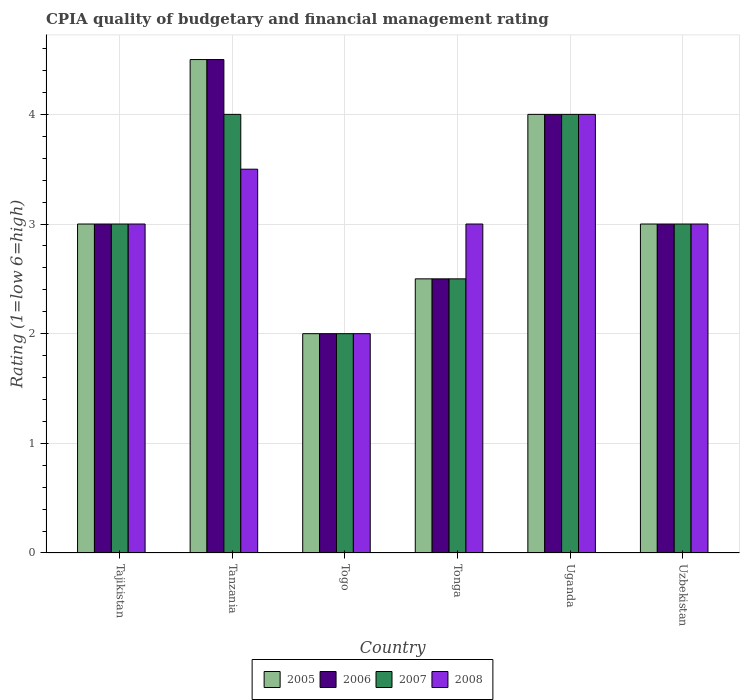How many groups of bars are there?
Ensure brevity in your answer.  6. Are the number of bars on each tick of the X-axis equal?
Offer a terse response. Yes. How many bars are there on the 4th tick from the left?
Your answer should be very brief. 4. What is the label of the 4th group of bars from the left?
Provide a succinct answer. Tonga. Across all countries, what is the maximum CPIA rating in 2005?
Give a very brief answer. 4.5. In which country was the CPIA rating in 2006 maximum?
Keep it short and to the point. Tanzania. In which country was the CPIA rating in 2007 minimum?
Offer a terse response. Togo. What is the total CPIA rating in 2005 in the graph?
Make the answer very short. 19. What is the difference between the CPIA rating in 2007 in Tanzania and that in Togo?
Your answer should be compact. 2. What is the average CPIA rating in 2005 per country?
Offer a terse response. 3.17. What is the ratio of the CPIA rating in 2005 in Tonga to that in Uzbekistan?
Provide a succinct answer. 0.83. Is the difference between the CPIA rating in 2006 in Tanzania and Uganda greater than the difference between the CPIA rating in 2005 in Tanzania and Uganda?
Make the answer very short. No. In how many countries, is the CPIA rating in 2008 greater than the average CPIA rating in 2008 taken over all countries?
Your response must be concise. 2. Is the sum of the CPIA rating in 2005 in Tanzania and Uganda greater than the maximum CPIA rating in 2006 across all countries?
Make the answer very short. Yes. Is it the case that in every country, the sum of the CPIA rating in 2008 and CPIA rating in 2005 is greater than the sum of CPIA rating in 2006 and CPIA rating in 2007?
Give a very brief answer. No. What does the 3rd bar from the left in Tajikistan represents?
Offer a terse response. 2007. What is the difference between two consecutive major ticks on the Y-axis?
Make the answer very short. 1. Does the graph contain any zero values?
Your answer should be compact. No. Does the graph contain grids?
Provide a short and direct response. Yes. How are the legend labels stacked?
Offer a terse response. Horizontal. What is the title of the graph?
Keep it short and to the point. CPIA quality of budgetary and financial management rating. What is the label or title of the X-axis?
Your response must be concise. Country. What is the label or title of the Y-axis?
Provide a short and direct response. Rating (1=low 6=high). What is the Rating (1=low 6=high) in 2005 in Tajikistan?
Provide a short and direct response. 3. What is the Rating (1=low 6=high) of 2006 in Tajikistan?
Offer a very short reply. 3. What is the Rating (1=low 6=high) of 2007 in Tajikistan?
Offer a very short reply. 3. What is the Rating (1=low 6=high) of 2008 in Tajikistan?
Your answer should be very brief. 3. What is the Rating (1=low 6=high) in 2005 in Tanzania?
Give a very brief answer. 4.5. What is the Rating (1=low 6=high) in 2007 in Tanzania?
Offer a very short reply. 4. What is the Rating (1=low 6=high) in 2006 in Togo?
Provide a succinct answer. 2. What is the Rating (1=low 6=high) in 2007 in Togo?
Your answer should be very brief. 2. What is the Rating (1=low 6=high) of 2008 in Togo?
Provide a short and direct response. 2. What is the Rating (1=low 6=high) in 2005 in Tonga?
Your response must be concise. 2.5. What is the Rating (1=low 6=high) of 2006 in Tonga?
Ensure brevity in your answer.  2.5. What is the Rating (1=low 6=high) in 2007 in Tonga?
Give a very brief answer. 2.5. What is the Rating (1=low 6=high) in 2008 in Tonga?
Your answer should be very brief. 3. What is the Rating (1=low 6=high) of 2006 in Uganda?
Ensure brevity in your answer.  4. What is the Rating (1=low 6=high) of 2008 in Uganda?
Your answer should be compact. 4. What is the Rating (1=low 6=high) in 2007 in Uzbekistan?
Make the answer very short. 3. Across all countries, what is the maximum Rating (1=low 6=high) in 2007?
Keep it short and to the point. 4. Across all countries, what is the maximum Rating (1=low 6=high) of 2008?
Give a very brief answer. 4. What is the total Rating (1=low 6=high) of 2006 in the graph?
Offer a very short reply. 19. What is the total Rating (1=low 6=high) of 2008 in the graph?
Ensure brevity in your answer.  18.5. What is the difference between the Rating (1=low 6=high) in 2007 in Tajikistan and that in Tanzania?
Your answer should be compact. -1. What is the difference between the Rating (1=low 6=high) of 2007 in Tajikistan and that in Tonga?
Ensure brevity in your answer.  0.5. What is the difference between the Rating (1=low 6=high) of 2008 in Tajikistan and that in Tonga?
Keep it short and to the point. 0. What is the difference between the Rating (1=low 6=high) in 2005 in Tajikistan and that in Uganda?
Provide a succinct answer. -1. What is the difference between the Rating (1=low 6=high) of 2006 in Tajikistan and that in Uganda?
Your response must be concise. -1. What is the difference between the Rating (1=low 6=high) in 2006 in Tajikistan and that in Uzbekistan?
Your response must be concise. 0. What is the difference between the Rating (1=low 6=high) in 2005 in Tanzania and that in Togo?
Your answer should be compact. 2.5. What is the difference between the Rating (1=low 6=high) in 2008 in Tanzania and that in Togo?
Offer a terse response. 1.5. What is the difference between the Rating (1=low 6=high) in 2005 in Tanzania and that in Tonga?
Give a very brief answer. 2. What is the difference between the Rating (1=low 6=high) in 2006 in Tanzania and that in Tonga?
Ensure brevity in your answer.  2. What is the difference between the Rating (1=low 6=high) of 2008 in Tanzania and that in Uganda?
Make the answer very short. -0.5. What is the difference between the Rating (1=low 6=high) in 2005 in Tanzania and that in Uzbekistan?
Give a very brief answer. 1.5. What is the difference between the Rating (1=low 6=high) of 2007 in Tanzania and that in Uzbekistan?
Offer a very short reply. 1. What is the difference between the Rating (1=low 6=high) in 2007 in Togo and that in Tonga?
Keep it short and to the point. -0.5. What is the difference between the Rating (1=low 6=high) in 2008 in Togo and that in Tonga?
Make the answer very short. -1. What is the difference between the Rating (1=low 6=high) in 2005 in Togo and that in Uganda?
Give a very brief answer. -2. What is the difference between the Rating (1=low 6=high) of 2007 in Togo and that in Uganda?
Provide a short and direct response. -2. What is the difference between the Rating (1=low 6=high) of 2008 in Togo and that in Uganda?
Keep it short and to the point. -2. What is the difference between the Rating (1=low 6=high) in 2006 in Togo and that in Uzbekistan?
Ensure brevity in your answer.  -1. What is the difference between the Rating (1=low 6=high) in 2008 in Tonga and that in Uganda?
Ensure brevity in your answer.  -1. What is the difference between the Rating (1=low 6=high) in 2006 in Tonga and that in Uzbekistan?
Offer a very short reply. -0.5. What is the difference between the Rating (1=low 6=high) in 2005 in Uganda and that in Uzbekistan?
Your response must be concise. 1. What is the difference between the Rating (1=low 6=high) in 2007 in Uganda and that in Uzbekistan?
Offer a very short reply. 1. What is the difference between the Rating (1=low 6=high) of 2008 in Uganda and that in Uzbekistan?
Offer a very short reply. 1. What is the difference between the Rating (1=low 6=high) of 2005 in Tajikistan and the Rating (1=low 6=high) of 2008 in Tanzania?
Ensure brevity in your answer.  -0.5. What is the difference between the Rating (1=low 6=high) in 2006 in Tajikistan and the Rating (1=low 6=high) in 2007 in Tanzania?
Make the answer very short. -1. What is the difference between the Rating (1=low 6=high) in 2007 in Tajikistan and the Rating (1=low 6=high) in 2008 in Tanzania?
Offer a very short reply. -0.5. What is the difference between the Rating (1=low 6=high) in 2005 in Tajikistan and the Rating (1=low 6=high) in 2006 in Togo?
Provide a short and direct response. 1. What is the difference between the Rating (1=low 6=high) of 2005 in Tajikistan and the Rating (1=low 6=high) of 2007 in Togo?
Provide a short and direct response. 1. What is the difference between the Rating (1=low 6=high) in 2005 in Tajikistan and the Rating (1=low 6=high) in 2008 in Togo?
Offer a terse response. 1. What is the difference between the Rating (1=low 6=high) in 2006 in Tajikistan and the Rating (1=low 6=high) in 2008 in Togo?
Your answer should be compact. 1. What is the difference between the Rating (1=low 6=high) of 2007 in Tajikistan and the Rating (1=low 6=high) of 2008 in Togo?
Your answer should be compact. 1. What is the difference between the Rating (1=low 6=high) in 2005 in Tajikistan and the Rating (1=low 6=high) in 2006 in Tonga?
Ensure brevity in your answer.  0.5. What is the difference between the Rating (1=low 6=high) in 2006 in Tajikistan and the Rating (1=low 6=high) in 2007 in Tonga?
Your answer should be very brief. 0.5. What is the difference between the Rating (1=low 6=high) in 2005 in Tajikistan and the Rating (1=low 6=high) in 2008 in Uganda?
Provide a short and direct response. -1. What is the difference between the Rating (1=low 6=high) of 2007 in Tajikistan and the Rating (1=low 6=high) of 2008 in Uganda?
Your response must be concise. -1. What is the difference between the Rating (1=low 6=high) in 2005 in Tajikistan and the Rating (1=low 6=high) in 2007 in Uzbekistan?
Offer a very short reply. 0. What is the difference between the Rating (1=low 6=high) of 2006 in Tajikistan and the Rating (1=low 6=high) of 2007 in Uzbekistan?
Offer a terse response. 0. What is the difference between the Rating (1=low 6=high) in 2006 in Tajikistan and the Rating (1=low 6=high) in 2008 in Uzbekistan?
Give a very brief answer. 0. What is the difference between the Rating (1=low 6=high) in 2005 in Tanzania and the Rating (1=low 6=high) in 2006 in Togo?
Provide a succinct answer. 2.5. What is the difference between the Rating (1=low 6=high) of 2006 in Tanzania and the Rating (1=low 6=high) of 2008 in Togo?
Offer a terse response. 2.5. What is the difference between the Rating (1=low 6=high) in 2005 in Tanzania and the Rating (1=low 6=high) in 2007 in Tonga?
Your response must be concise. 2. What is the difference between the Rating (1=low 6=high) in 2005 in Tanzania and the Rating (1=low 6=high) in 2008 in Tonga?
Provide a succinct answer. 1.5. What is the difference between the Rating (1=low 6=high) of 2006 in Tanzania and the Rating (1=low 6=high) of 2008 in Tonga?
Make the answer very short. 1.5. What is the difference between the Rating (1=low 6=high) in 2005 in Tanzania and the Rating (1=low 6=high) in 2007 in Uganda?
Keep it short and to the point. 0.5. What is the difference between the Rating (1=low 6=high) in 2005 in Tanzania and the Rating (1=low 6=high) in 2008 in Uganda?
Keep it short and to the point. 0.5. What is the difference between the Rating (1=low 6=high) in 2006 in Tanzania and the Rating (1=low 6=high) in 2008 in Uganda?
Make the answer very short. 0.5. What is the difference between the Rating (1=low 6=high) in 2005 in Tanzania and the Rating (1=low 6=high) in 2006 in Uzbekistan?
Give a very brief answer. 1.5. What is the difference between the Rating (1=low 6=high) of 2005 in Tanzania and the Rating (1=low 6=high) of 2007 in Uzbekistan?
Make the answer very short. 1.5. What is the difference between the Rating (1=low 6=high) of 2006 in Tanzania and the Rating (1=low 6=high) of 2007 in Uzbekistan?
Your answer should be compact. 1.5. What is the difference between the Rating (1=low 6=high) in 2007 in Tanzania and the Rating (1=low 6=high) in 2008 in Uzbekistan?
Offer a terse response. 1. What is the difference between the Rating (1=low 6=high) of 2005 in Togo and the Rating (1=low 6=high) of 2006 in Tonga?
Offer a very short reply. -0.5. What is the difference between the Rating (1=low 6=high) in 2005 in Togo and the Rating (1=low 6=high) in 2008 in Tonga?
Your response must be concise. -1. What is the difference between the Rating (1=low 6=high) of 2006 in Togo and the Rating (1=low 6=high) of 2007 in Tonga?
Ensure brevity in your answer.  -0.5. What is the difference between the Rating (1=low 6=high) in 2006 in Togo and the Rating (1=low 6=high) in 2008 in Tonga?
Provide a succinct answer. -1. What is the difference between the Rating (1=low 6=high) in 2007 in Togo and the Rating (1=low 6=high) in 2008 in Tonga?
Offer a very short reply. -1. What is the difference between the Rating (1=low 6=high) in 2006 in Togo and the Rating (1=low 6=high) in 2008 in Uganda?
Give a very brief answer. -2. What is the difference between the Rating (1=low 6=high) of 2007 in Togo and the Rating (1=low 6=high) of 2008 in Uganda?
Provide a short and direct response. -2. What is the difference between the Rating (1=low 6=high) of 2005 in Togo and the Rating (1=low 6=high) of 2006 in Uzbekistan?
Make the answer very short. -1. What is the difference between the Rating (1=low 6=high) of 2005 in Togo and the Rating (1=low 6=high) of 2007 in Uzbekistan?
Ensure brevity in your answer.  -1. What is the difference between the Rating (1=low 6=high) in 2006 in Togo and the Rating (1=low 6=high) in 2007 in Uzbekistan?
Offer a terse response. -1. What is the difference between the Rating (1=low 6=high) of 2007 in Togo and the Rating (1=low 6=high) of 2008 in Uzbekistan?
Provide a succinct answer. -1. What is the difference between the Rating (1=low 6=high) of 2005 in Tonga and the Rating (1=low 6=high) of 2008 in Uganda?
Your answer should be compact. -1.5. What is the difference between the Rating (1=low 6=high) in 2006 in Tonga and the Rating (1=low 6=high) in 2007 in Uganda?
Keep it short and to the point. -1.5. What is the difference between the Rating (1=low 6=high) in 2005 in Tonga and the Rating (1=low 6=high) in 2006 in Uzbekistan?
Keep it short and to the point. -0.5. What is the difference between the Rating (1=low 6=high) of 2005 in Tonga and the Rating (1=low 6=high) of 2008 in Uzbekistan?
Make the answer very short. -0.5. What is the difference between the Rating (1=low 6=high) of 2006 in Tonga and the Rating (1=low 6=high) of 2007 in Uzbekistan?
Provide a short and direct response. -0.5. What is the difference between the Rating (1=low 6=high) in 2006 in Tonga and the Rating (1=low 6=high) in 2008 in Uzbekistan?
Give a very brief answer. -0.5. What is the difference between the Rating (1=low 6=high) of 2007 in Tonga and the Rating (1=low 6=high) of 2008 in Uzbekistan?
Your answer should be very brief. -0.5. What is the difference between the Rating (1=low 6=high) of 2005 in Uganda and the Rating (1=low 6=high) of 2007 in Uzbekistan?
Offer a terse response. 1. What is the difference between the Rating (1=low 6=high) in 2006 in Uganda and the Rating (1=low 6=high) in 2007 in Uzbekistan?
Ensure brevity in your answer.  1. What is the average Rating (1=low 6=high) in 2005 per country?
Make the answer very short. 3.17. What is the average Rating (1=low 6=high) of 2006 per country?
Give a very brief answer. 3.17. What is the average Rating (1=low 6=high) of 2007 per country?
Make the answer very short. 3.08. What is the average Rating (1=low 6=high) of 2008 per country?
Your response must be concise. 3.08. What is the difference between the Rating (1=low 6=high) of 2005 and Rating (1=low 6=high) of 2006 in Tajikistan?
Provide a short and direct response. 0. What is the difference between the Rating (1=low 6=high) in 2005 and Rating (1=low 6=high) in 2008 in Tajikistan?
Offer a terse response. 0. What is the difference between the Rating (1=low 6=high) of 2006 and Rating (1=low 6=high) of 2007 in Tajikistan?
Make the answer very short. 0. What is the difference between the Rating (1=low 6=high) of 2005 and Rating (1=low 6=high) of 2006 in Tanzania?
Offer a terse response. 0. What is the difference between the Rating (1=low 6=high) of 2005 and Rating (1=low 6=high) of 2007 in Tanzania?
Make the answer very short. 0.5. What is the difference between the Rating (1=low 6=high) of 2005 and Rating (1=low 6=high) of 2008 in Tanzania?
Make the answer very short. 1. What is the difference between the Rating (1=low 6=high) in 2007 and Rating (1=low 6=high) in 2008 in Tanzania?
Your response must be concise. 0.5. What is the difference between the Rating (1=low 6=high) in 2005 and Rating (1=low 6=high) in 2006 in Togo?
Keep it short and to the point. 0. What is the difference between the Rating (1=low 6=high) of 2006 and Rating (1=low 6=high) of 2007 in Tonga?
Your response must be concise. 0. What is the difference between the Rating (1=low 6=high) in 2006 and Rating (1=low 6=high) in 2008 in Tonga?
Keep it short and to the point. -0.5. What is the difference between the Rating (1=low 6=high) of 2005 and Rating (1=low 6=high) of 2006 in Uganda?
Offer a terse response. 0. What is the difference between the Rating (1=low 6=high) in 2006 and Rating (1=low 6=high) in 2008 in Uganda?
Your response must be concise. 0. What is the difference between the Rating (1=low 6=high) of 2007 and Rating (1=low 6=high) of 2008 in Uganda?
Make the answer very short. 0. What is the difference between the Rating (1=low 6=high) in 2005 and Rating (1=low 6=high) in 2006 in Uzbekistan?
Keep it short and to the point. 0. What is the difference between the Rating (1=low 6=high) of 2005 and Rating (1=low 6=high) of 2007 in Uzbekistan?
Your response must be concise. 0. What is the difference between the Rating (1=low 6=high) of 2005 and Rating (1=low 6=high) of 2008 in Uzbekistan?
Make the answer very short. 0. What is the difference between the Rating (1=low 6=high) of 2006 and Rating (1=low 6=high) of 2007 in Uzbekistan?
Make the answer very short. 0. What is the difference between the Rating (1=low 6=high) in 2006 and Rating (1=low 6=high) in 2008 in Uzbekistan?
Make the answer very short. 0. What is the ratio of the Rating (1=low 6=high) of 2008 in Tajikistan to that in Tanzania?
Ensure brevity in your answer.  0.86. What is the ratio of the Rating (1=low 6=high) of 2006 in Tajikistan to that in Togo?
Your response must be concise. 1.5. What is the ratio of the Rating (1=low 6=high) of 2007 in Tajikistan to that in Togo?
Provide a short and direct response. 1.5. What is the ratio of the Rating (1=low 6=high) of 2008 in Tajikistan to that in Togo?
Ensure brevity in your answer.  1.5. What is the ratio of the Rating (1=low 6=high) in 2008 in Tajikistan to that in Tonga?
Keep it short and to the point. 1. What is the ratio of the Rating (1=low 6=high) of 2006 in Tajikistan to that in Uganda?
Ensure brevity in your answer.  0.75. What is the ratio of the Rating (1=low 6=high) in 2005 in Tajikistan to that in Uzbekistan?
Your answer should be very brief. 1. What is the ratio of the Rating (1=low 6=high) in 2008 in Tajikistan to that in Uzbekistan?
Ensure brevity in your answer.  1. What is the ratio of the Rating (1=low 6=high) in 2005 in Tanzania to that in Togo?
Make the answer very short. 2.25. What is the ratio of the Rating (1=low 6=high) in 2006 in Tanzania to that in Togo?
Your answer should be compact. 2.25. What is the ratio of the Rating (1=low 6=high) in 2008 in Tanzania to that in Togo?
Give a very brief answer. 1.75. What is the ratio of the Rating (1=low 6=high) in 2007 in Tanzania to that in Tonga?
Offer a very short reply. 1.6. What is the ratio of the Rating (1=low 6=high) of 2005 in Tanzania to that in Uganda?
Provide a succinct answer. 1.12. What is the ratio of the Rating (1=low 6=high) in 2006 in Tanzania to that in Uganda?
Make the answer very short. 1.12. What is the ratio of the Rating (1=low 6=high) in 2008 in Tanzania to that in Uganda?
Keep it short and to the point. 0.88. What is the ratio of the Rating (1=low 6=high) of 2005 in Tanzania to that in Uzbekistan?
Make the answer very short. 1.5. What is the ratio of the Rating (1=low 6=high) of 2006 in Tanzania to that in Uzbekistan?
Your answer should be compact. 1.5. What is the ratio of the Rating (1=low 6=high) of 2007 in Tanzania to that in Uzbekistan?
Your answer should be compact. 1.33. What is the ratio of the Rating (1=low 6=high) of 2008 in Tanzania to that in Uzbekistan?
Keep it short and to the point. 1.17. What is the ratio of the Rating (1=low 6=high) of 2005 in Togo to that in Tonga?
Make the answer very short. 0.8. What is the ratio of the Rating (1=low 6=high) of 2007 in Togo to that in Tonga?
Make the answer very short. 0.8. What is the ratio of the Rating (1=low 6=high) of 2005 in Togo to that in Uganda?
Keep it short and to the point. 0.5. What is the ratio of the Rating (1=low 6=high) of 2006 in Togo to that in Uganda?
Offer a very short reply. 0.5. What is the ratio of the Rating (1=low 6=high) of 2006 in Togo to that in Uzbekistan?
Give a very brief answer. 0.67. What is the ratio of the Rating (1=low 6=high) in 2007 in Togo to that in Uzbekistan?
Keep it short and to the point. 0.67. What is the ratio of the Rating (1=low 6=high) of 2008 in Togo to that in Uzbekistan?
Provide a succinct answer. 0.67. What is the ratio of the Rating (1=low 6=high) of 2005 in Tonga to that in Uganda?
Your answer should be compact. 0.62. What is the ratio of the Rating (1=low 6=high) in 2006 in Tonga to that in Uganda?
Your response must be concise. 0.62. What is the ratio of the Rating (1=low 6=high) of 2007 in Tonga to that in Uganda?
Your response must be concise. 0.62. What is the ratio of the Rating (1=low 6=high) in 2008 in Tonga to that in Uganda?
Provide a succinct answer. 0.75. What is the ratio of the Rating (1=low 6=high) of 2006 in Tonga to that in Uzbekistan?
Your response must be concise. 0.83. What is the ratio of the Rating (1=low 6=high) of 2007 in Tonga to that in Uzbekistan?
Keep it short and to the point. 0.83. What is the ratio of the Rating (1=low 6=high) in 2005 in Uganda to that in Uzbekistan?
Offer a very short reply. 1.33. What is the ratio of the Rating (1=low 6=high) of 2006 in Uganda to that in Uzbekistan?
Provide a short and direct response. 1.33. What is the ratio of the Rating (1=low 6=high) in 2007 in Uganda to that in Uzbekistan?
Your response must be concise. 1.33. What is the difference between the highest and the second highest Rating (1=low 6=high) in 2005?
Your response must be concise. 0.5. What is the difference between the highest and the second highest Rating (1=low 6=high) of 2008?
Ensure brevity in your answer.  0.5. What is the difference between the highest and the lowest Rating (1=low 6=high) of 2007?
Offer a terse response. 2. 